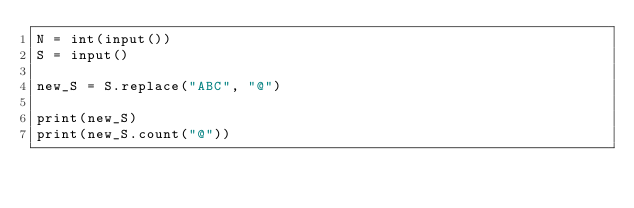<code> <loc_0><loc_0><loc_500><loc_500><_Python_>N = int(input())
S = input()

new_S = S.replace("ABC", "@")

print(new_S)
print(new_S.count("@"))
</code> 